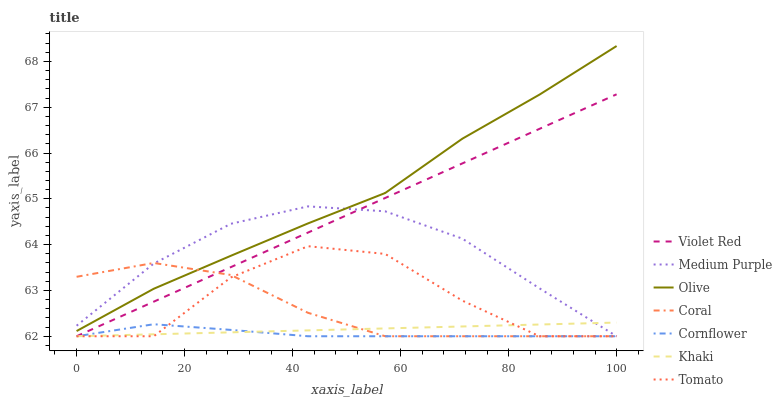Does Cornflower have the minimum area under the curve?
Answer yes or no. Yes. Does Olive have the maximum area under the curve?
Answer yes or no. Yes. Does Violet Red have the minimum area under the curve?
Answer yes or no. No. Does Violet Red have the maximum area under the curve?
Answer yes or no. No. Is Khaki the smoothest?
Answer yes or no. Yes. Is Tomato the roughest?
Answer yes or no. Yes. Is Cornflower the smoothest?
Answer yes or no. No. Is Cornflower the roughest?
Answer yes or no. No. Does Olive have the lowest value?
Answer yes or no. No. Does Olive have the highest value?
Answer yes or no. Yes. Does Violet Red have the highest value?
Answer yes or no. No. Is Violet Red less than Olive?
Answer yes or no. Yes. Is Olive greater than Violet Red?
Answer yes or no. Yes. Does Tomato intersect Khaki?
Answer yes or no. Yes. Is Tomato less than Khaki?
Answer yes or no. No. Is Tomato greater than Khaki?
Answer yes or no. No. Does Violet Red intersect Olive?
Answer yes or no. No. 